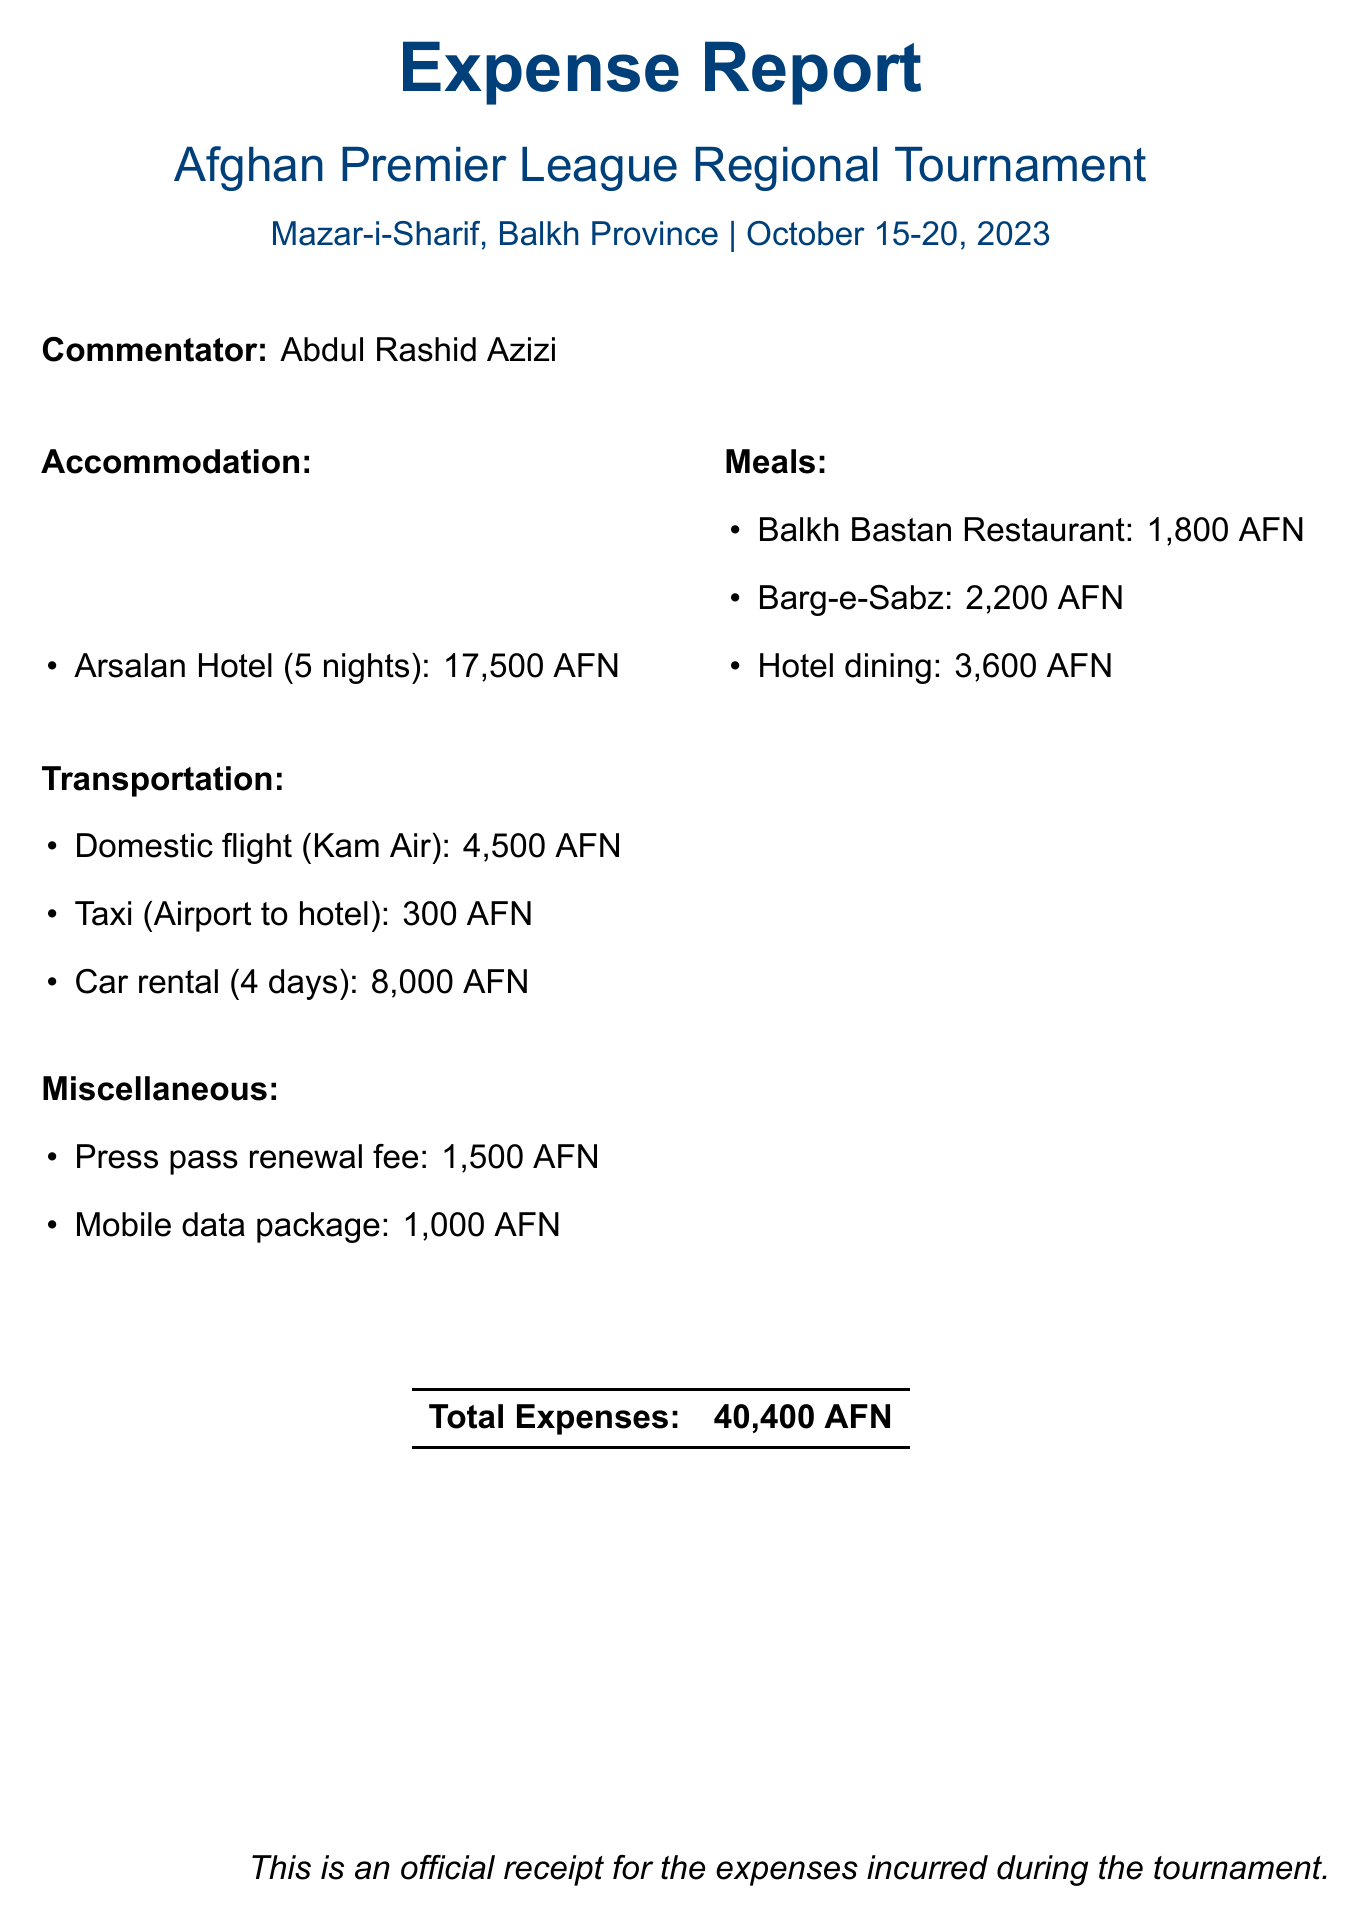what is the name of the tournament? The document clearly states the name of the tournament at the beginning.
Answer: Afghan Premier League Regional Tournament what is the location of the tournament? The location is mentioned right after the tournament name.
Answer: Mazar-i-Sharif, Balkh Province who is the commentator? The commentator's name is provided under the commentator section.
Answer: Abdul Rashid Azizi how many nights did the accommodation last? The number of nights for accommodation is detailed in the accommodation section.
Answer: 5 what is the total cost of meals? The total cost of meals can be found by adding all individual meal costs in the meals section.
Answer: 7200 AFN which flight provider was used for transportation? The transportation section lists the provider for the domestic flight.
Answer: Kam Air how much was spent on the taxi? The cost for the taxi service to the hotel is specified under transportation.
Answer: 300 AFN what is the total expense reported? The total expenses amount is mentioned as part of the conclusion in the document.
Answer: 40400 AFN how much was spent on miscellaneous items? The total cost of miscellaneous items can be found by adding the costs of individual items listed in the miscellaneous section.
Answer: 2500 AFN 